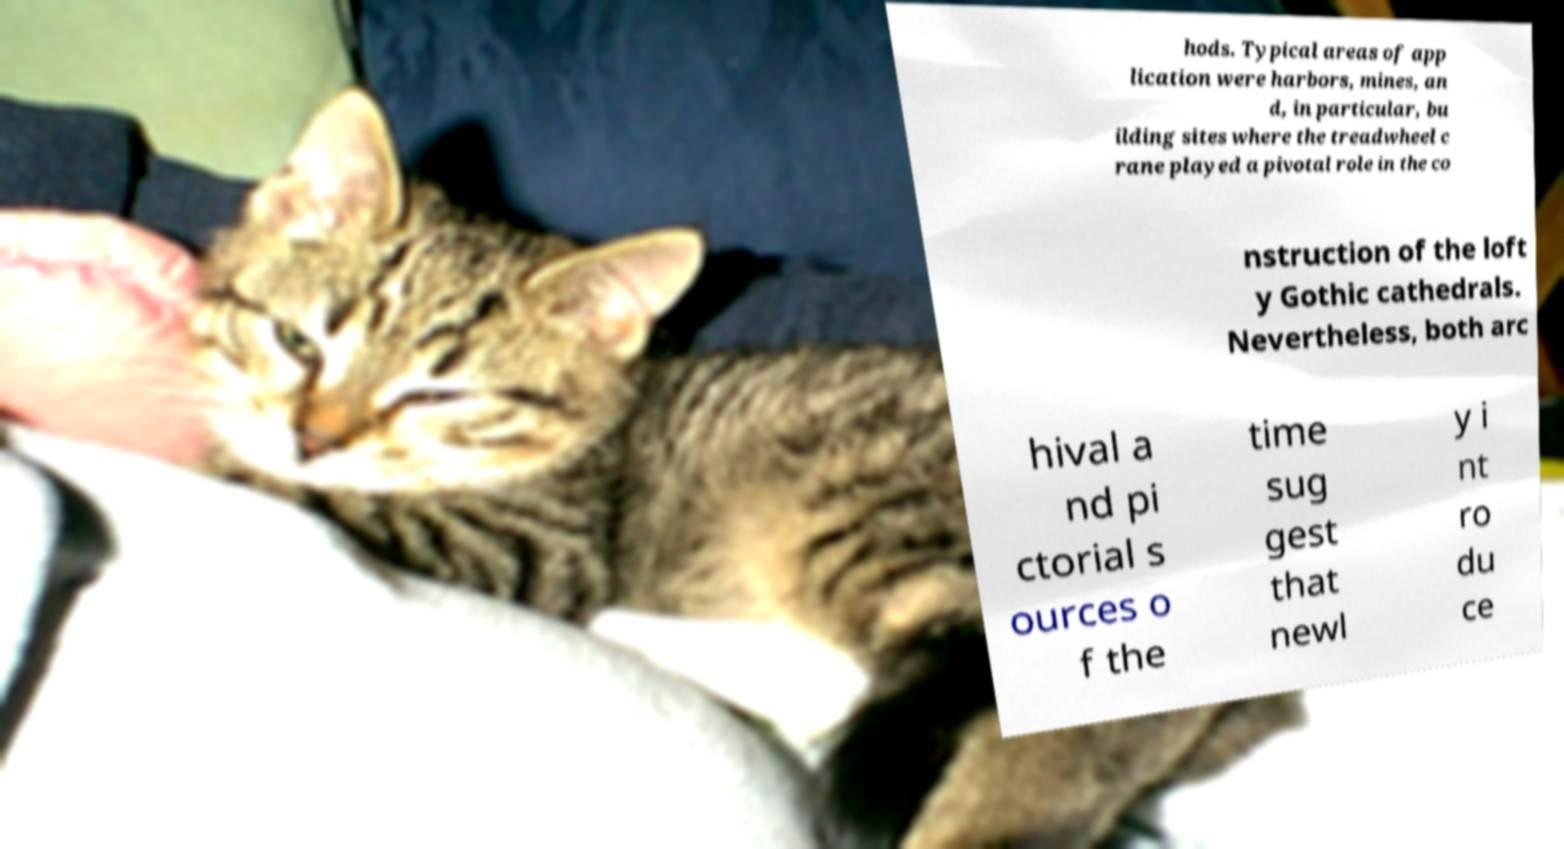Can you accurately transcribe the text from the provided image for me? hods. Typical areas of app lication were harbors, mines, an d, in particular, bu ilding sites where the treadwheel c rane played a pivotal role in the co nstruction of the loft y Gothic cathedrals. Nevertheless, both arc hival a nd pi ctorial s ources o f the time sug gest that newl y i nt ro du ce 